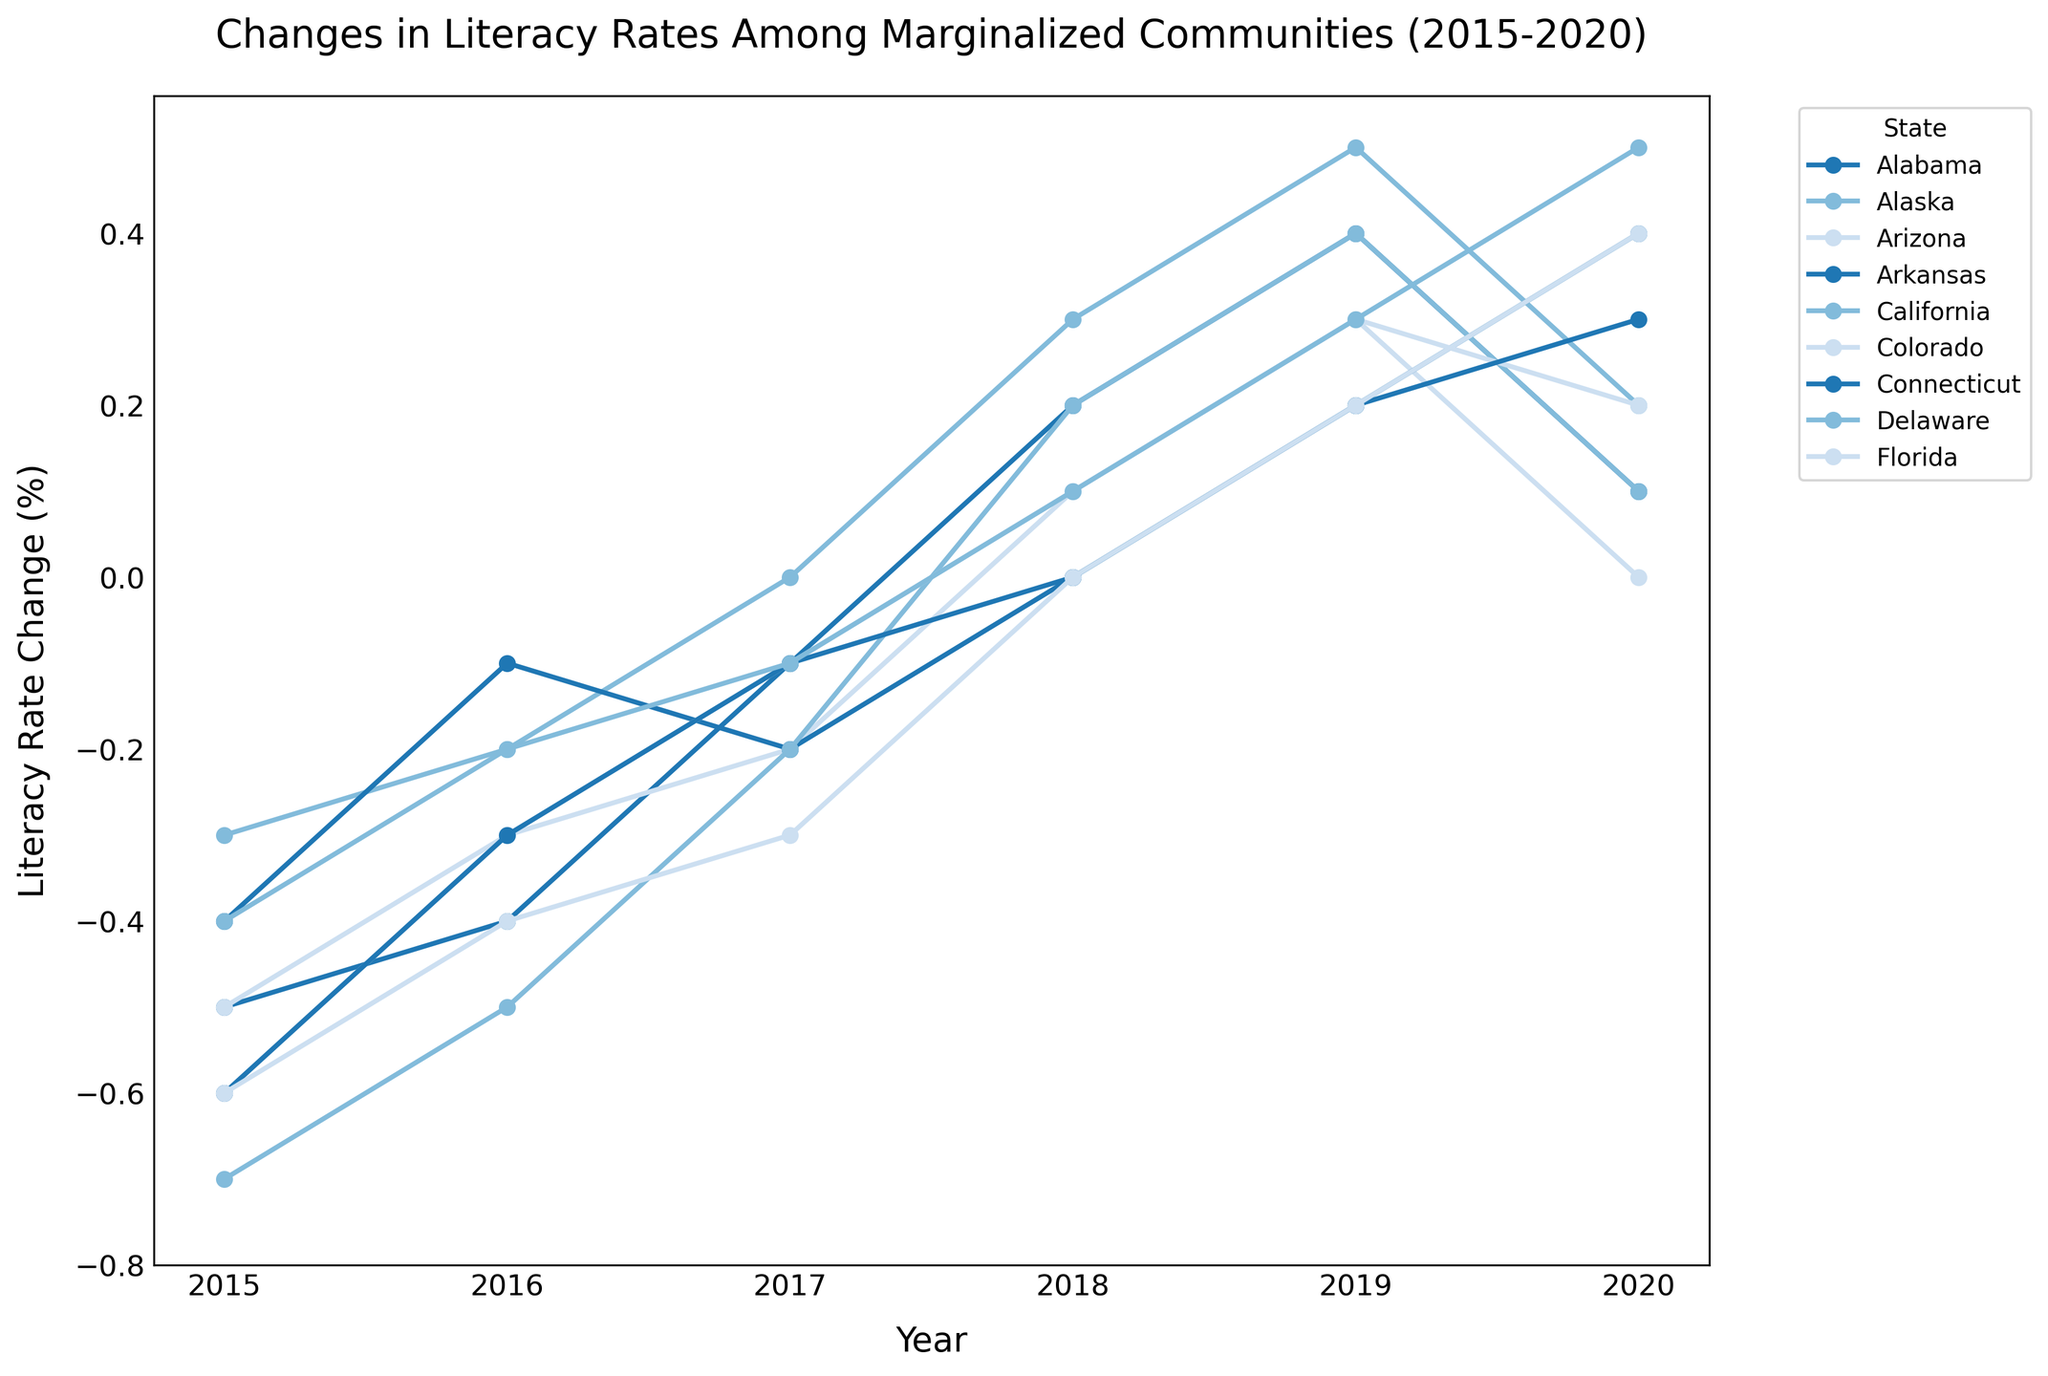Which state had the highest increase in literacy rate change by 2020? To find the state with the highest increase, compare the literacy rate changes for all states in the year 2020. Delaware has the highest value of 0.5.
Answer: Delaware Which year did Arizona experience its first positive change in literacy rate? Look at the line for Arizona and identify the first year where the literacy rate change is above 0. The year is 2018.
Answer: 2018 How many states had a negative literacy rate change in 2015? Count the number of states that have values below 0 for the year 2015. There are 8 states (Alabama, Alaska, Arizona, Arkansas, California, Colorado, Connecticut, Florida).
Answer: 8 Between 2017 and 2018, which state had the greatest improvement in literacy rate change? Determine the difference in literacy rate change for each state between 2017 and 2018, and find the state with the highest positive difference. California had a change from -0.2 to 0.2, which is an improvement of 0.4.
Answer: California Which state showed a consistent positive trend in literacy rate change from 2015 to 2019 without any setbacks? Review the data for each state from 2015 to 2019 and find the one where literacy rate change continuously increases. The state is Alaska.
Answer: Alaska What is the difference in literacy rate change between Alabama and Connecticut in 2020? Find the literacy rate change for Alabama and Connecticut in 2020 and calculate the difference. Alabama has 0.1 and Connecticut has 0.3; the difference is 0.3 - 0.1 = 0.2.
Answer: 0.2 Which year did Florida transition from a negative to a positive literacy rate change? Find where Florida's literacy rate change crosses from negative to positive. This happens between 2017 and 2018 when it goes from -0.3 to 0.0.
Answer: 2018 What is the average literacy rate change for Colorado from 2015 to 2020? Sum up all the literacy rate changes for Colorado from 2015 to 2020 and divide by the number of years: (-0.5) + (-0.3) + (-0.1) + 0.1 + 0.3 + 0.2 = -0.3; the average is -0.3 / 6 ≈ -0.05.
Answer: -0.05 